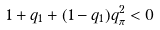Convert formula to latex. <formula><loc_0><loc_0><loc_500><loc_500>1 + q _ { 1 } + ( 1 - q _ { 1 } ) q ^ { 2 } _ { \pi } < 0</formula> 